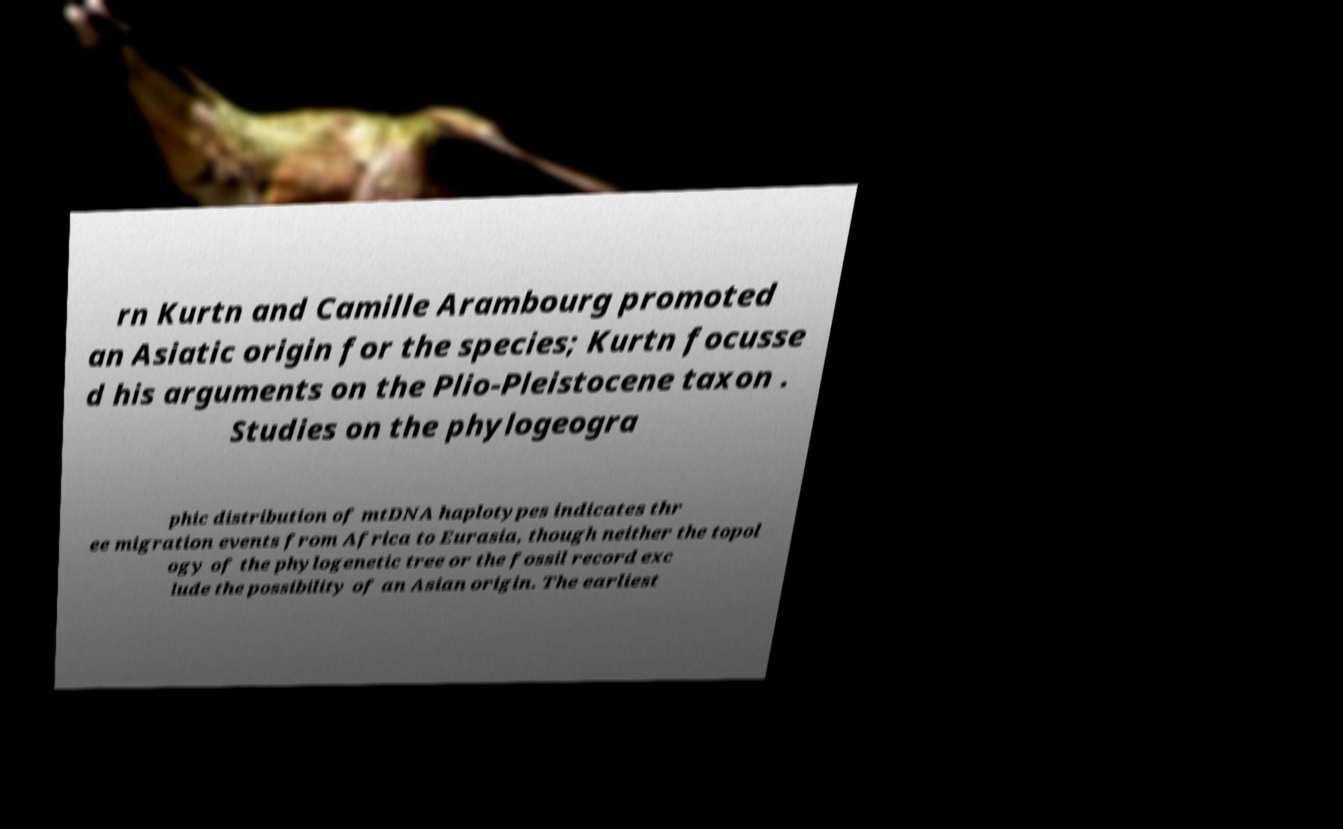Please read and relay the text visible in this image. What does it say? rn Kurtn and Camille Arambourg promoted an Asiatic origin for the species; Kurtn focusse d his arguments on the Plio-Pleistocene taxon . Studies on the phylogeogra phic distribution of mtDNA haplotypes indicates thr ee migration events from Africa to Eurasia, though neither the topol ogy of the phylogenetic tree or the fossil record exc lude the possibility of an Asian origin. The earliest 